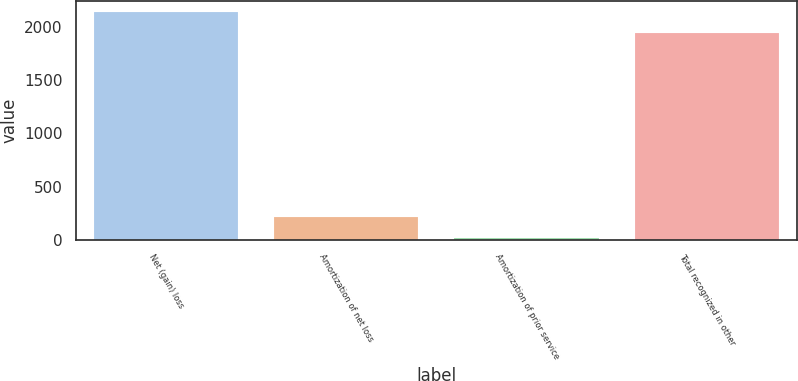Convert chart to OTSL. <chart><loc_0><loc_0><loc_500><loc_500><bar_chart><fcel>Net (gain) loss<fcel>Amortization of net loss<fcel>Amortization of prior service<fcel>Total recognized in other<nl><fcel>2140.6<fcel>211.6<fcel>14<fcel>1943<nl></chart> 